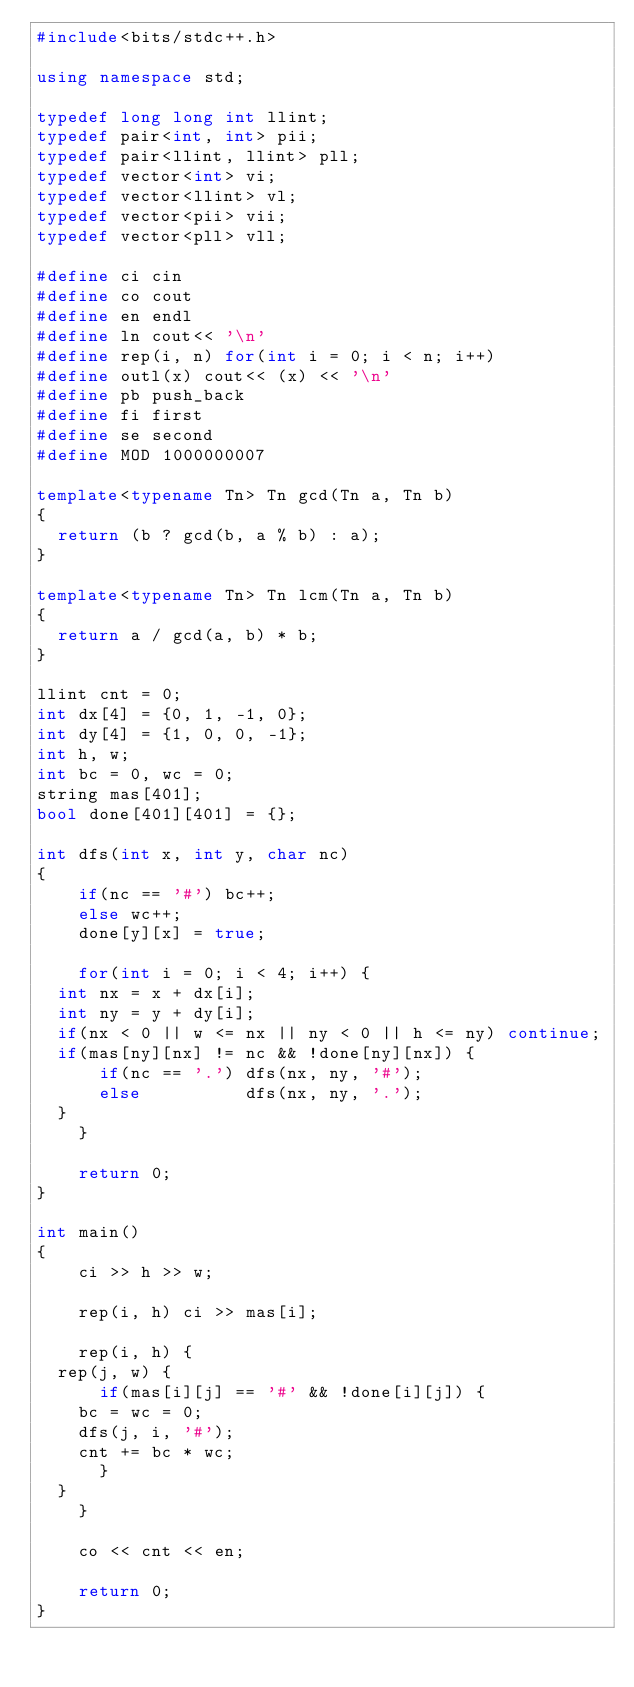<code> <loc_0><loc_0><loc_500><loc_500><_C++_>#include<bits/stdc++.h>

using namespace std;

typedef long long int llint;
typedef pair<int, int> pii;
typedef pair<llint, llint> pll;
typedef vector<int> vi;
typedef vector<llint> vl;
typedef vector<pii> vii;
typedef vector<pll> vll;

#define ci cin
#define co cout
#define en endl
#define ln cout<< '\n'
#define rep(i, n) for(int i = 0; i < n; i++)
#define outl(x) cout<< (x) << '\n'
#define pb push_back
#define fi first
#define se second
#define MOD 1000000007

template<typename Tn> Tn gcd(Tn a, Tn b)
{
	return (b ? gcd(b, a % b) : a);
}

template<typename Tn> Tn lcm(Tn a, Tn b)
{
	return a / gcd(a, b) * b;
}

llint cnt = 0;
int dx[4] = {0, 1, -1, 0};
int dy[4] = {1, 0, 0, -1};
int h, w;
int bc = 0, wc = 0;
string mas[401];
bool done[401][401] = {};

int dfs(int x, int y, char nc)
{
    if(nc == '#') bc++;
    else wc++;
    done[y][x] = true;
    
    for(int i = 0; i < 4; i++) {
	int nx = x + dx[i];
	int ny = y + dy[i];
	if(nx < 0 || w <= nx || ny < 0 || h <= ny) continue;
	if(mas[ny][nx] != nc && !done[ny][nx]) {
	    if(nc == '.') dfs(nx, ny, '#');
	    else          dfs(nx, ny, '.');
	}
    }
    
    return 0;
}

int main()
{
    ci >> h >> w;

    rep(i, h) ci >> mas[i];
    
    rep(i, h) {
	rep(j, w) {
	    if(mas[i][j] == '#' && !done[i][j]) {
		bc = wc = 0;
		dfs(j, i, '#');
		cnt += bc * wc;
	    }
	}
    }
	    
    co << cnt << en;
    
    return 0;
}
</code> 